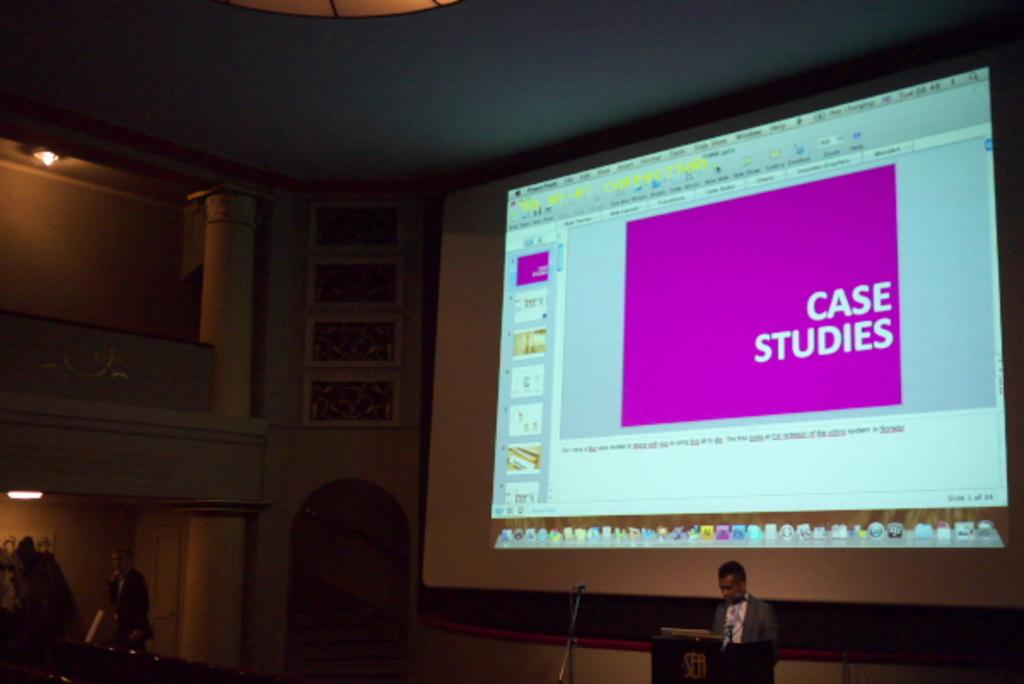<image>
Present a compact description of the photo's key features. a projector in back of a man at a podium  that says 'case studies' on it 